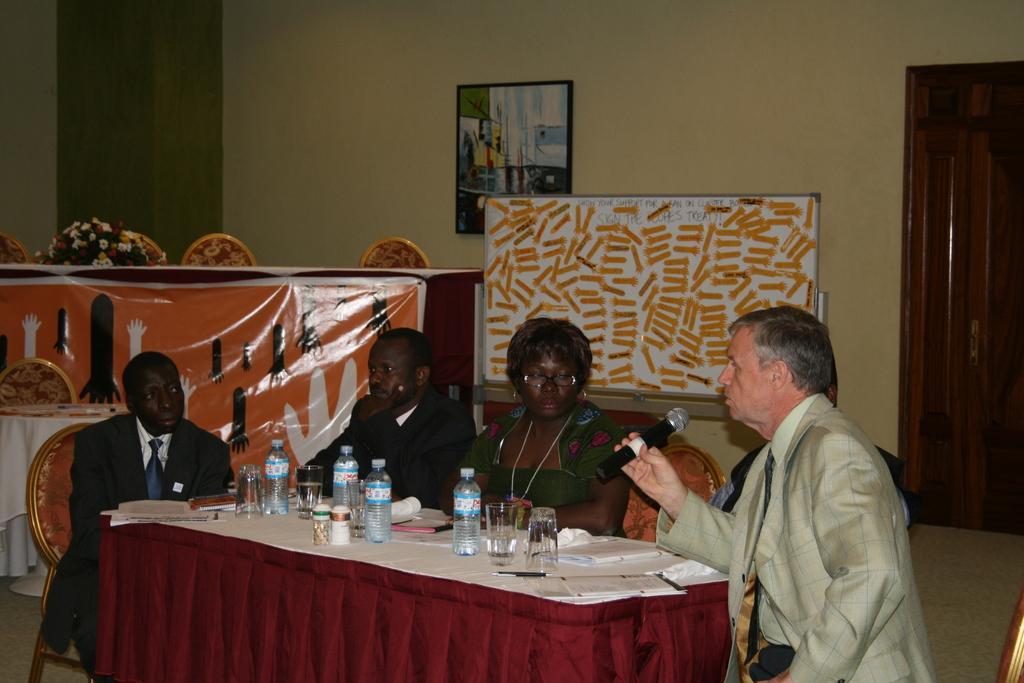Describe this image in one or two sentences. In this image few persons are sitting on a chair before a table having glasses , bottles, papers and pen on it. Person wearing a green colour suit is holding a mike. Backside of them there is a board having some text written on it. At the left side there are few chairs, table having flower vase on it. There is a picture frame attached to it. At the right side there is a door. 